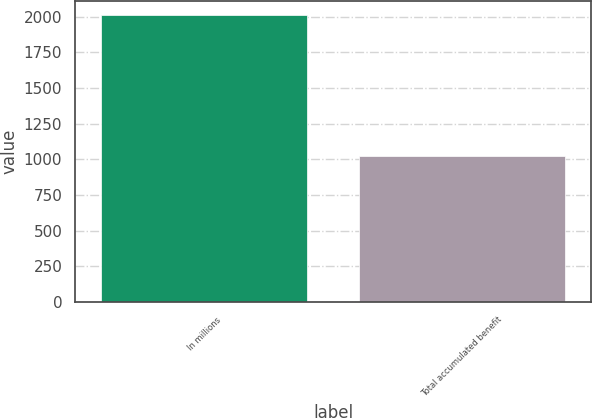Convert chart. <chart><loc_0><loc_0><loc_500><loc_500><bar_chart><fcel>In millions<fcel>Total accumulated benefit<nl><fcel>2011<fcel>1027<nl></chart> 